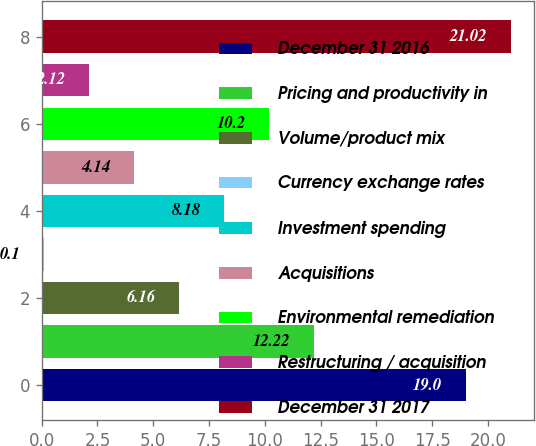Convert chart. <chart><loc_0><loc_0><loc_500><loc_500><bar_chart><fcel>December 31 2016<fcel>Pricing and productivity in<fcel>Volume/product mix<fcel>Currency exchange rates<fcel>Investment spending<fcel>Acquisitions<fcel>Environmental remediation<fcel>Restructuring / acquisition<fcel>December 31 2017<nl><fcel>19<fcel>12.22<fcel>6.16<fcel>0.1<fcel>8.18<fcel>4.14<fcel>10.2<fcel>2.12<fcel>21.02<nl></chart> 